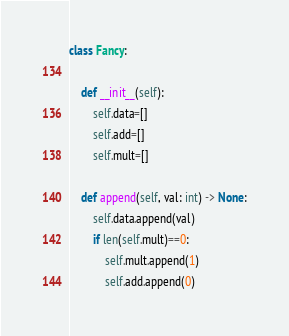<code> <loc_0><loc_0><loc_500><loc_500><_Python_>class Fancy:

    def __init__(self):
        self.data=[]
        self.add=[]
        self.mult=[]

    def append(self, val: int) -> None:
        self.data.append(val)
        if len(self.mult)==0:
            self.mult.append(1)
            self.add.append(0)</code> 